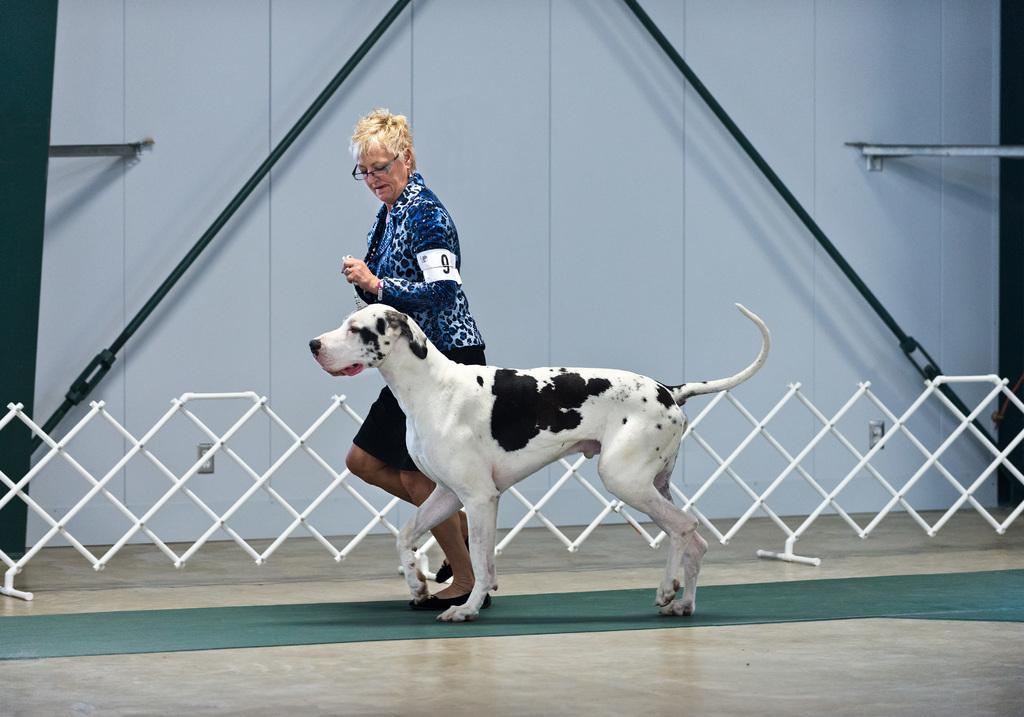Who is present in the image? There is a woman in the image. What is the dog doing in the image? The dog is walking in the image. What is the dog's current state of motion? The dog is walking. What type of architectural feature can be seen in the image? There is a railing and a wall in the image. What is located at the bottom of the image? There is a mat at the bottom of the image. What type of field is visible in the image? There is no field visible in the image. Is the queen present in the image? There is no queen present in the image. 